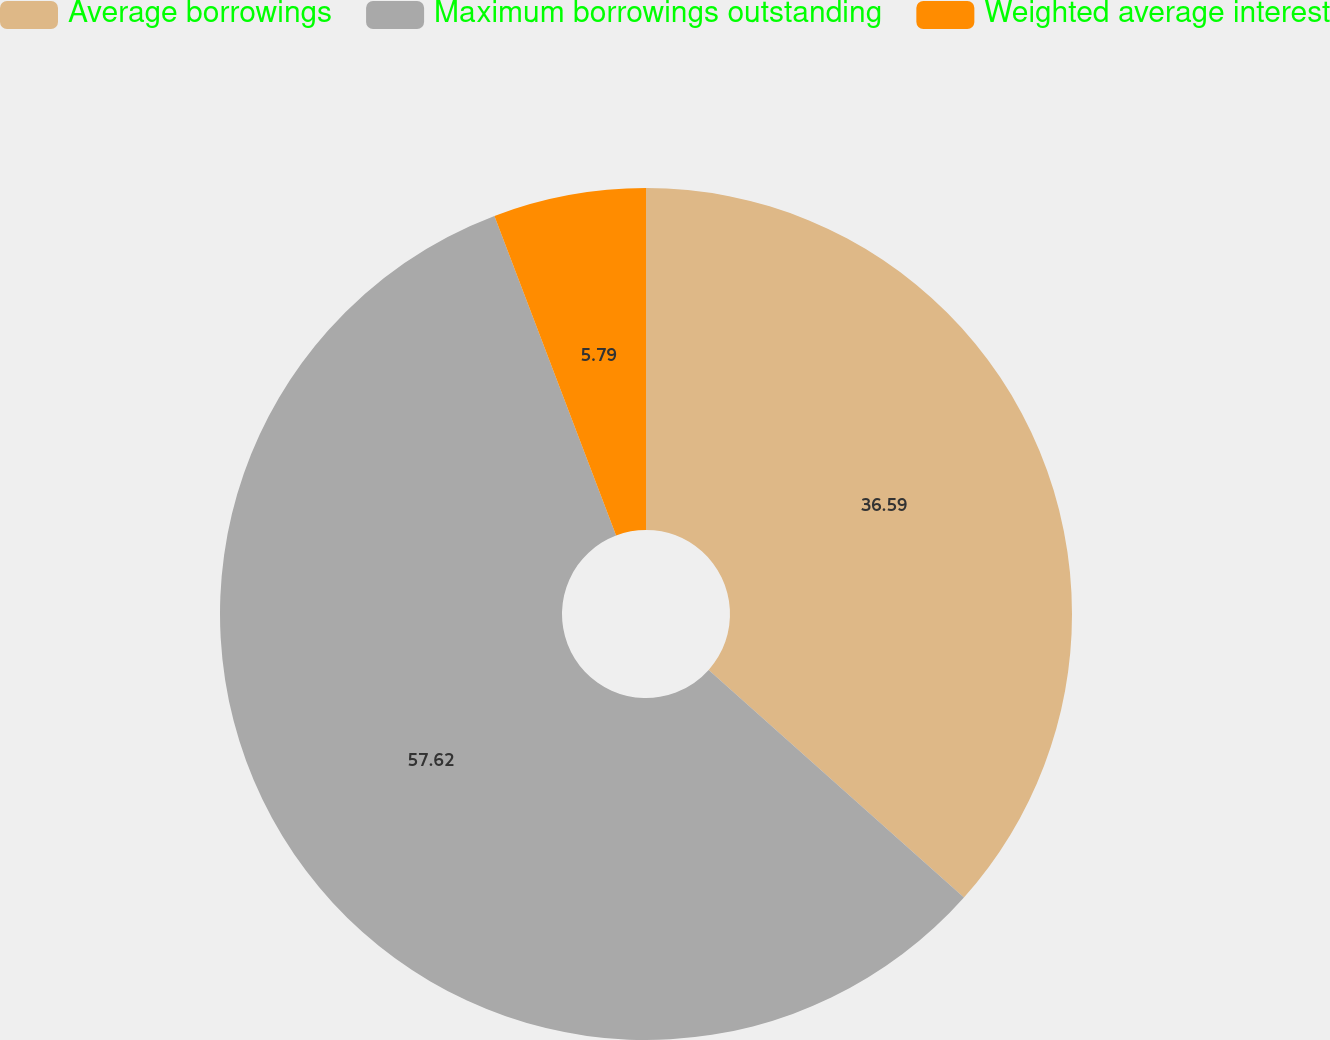Convert chart to OTSL. <chart><loc_0><loc_0><loc_500><loc_500><pie_chart><fcel>Average borrowings<fcel>Maximum borrowings outstanding<fcel>Weighted average interest<nl><fcel>36.59%<fcel>57.62%<fcel>5.79%<nl></chart> 